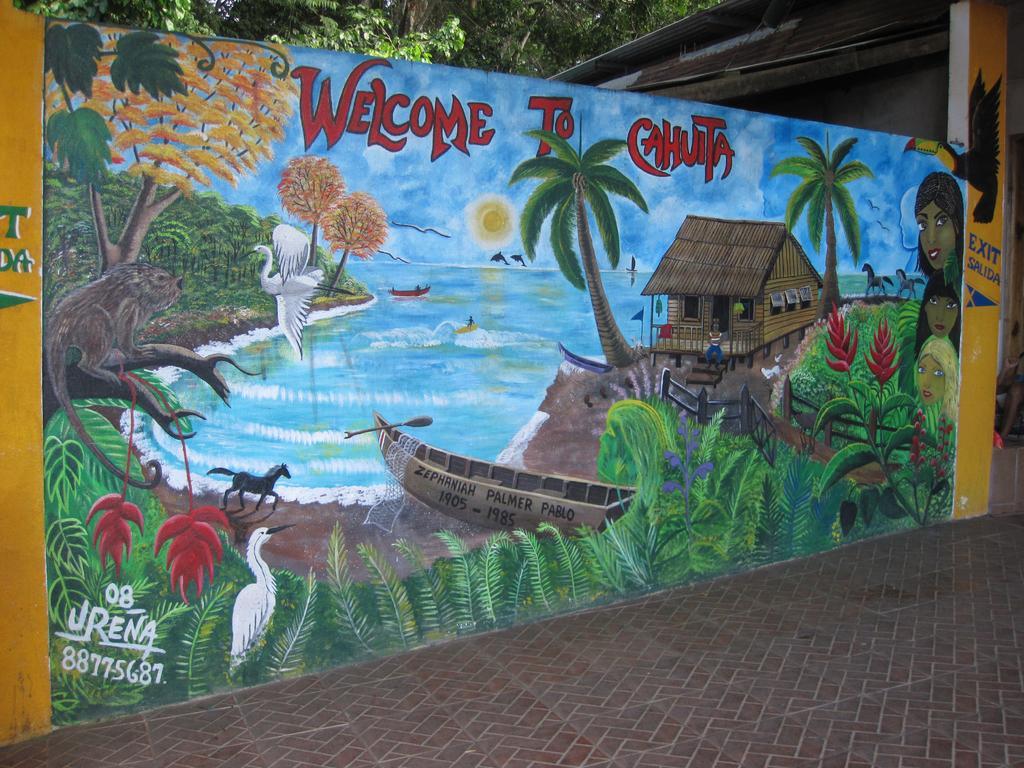In one or two sentences, can you explain what this image depicts? As we can see in the image there is a banner and trees. On banner there is painting of plants, boat, water, horse, trees, sky, clouds and house. 